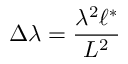Convert formula to latex. <formula><loc_0><loc_0><loc_500><loc_500>\Delta \lambda = \frac { \lambda ^ { 2 } \ell ^ { \ast } } { L ^ { 2 } }</formula> 